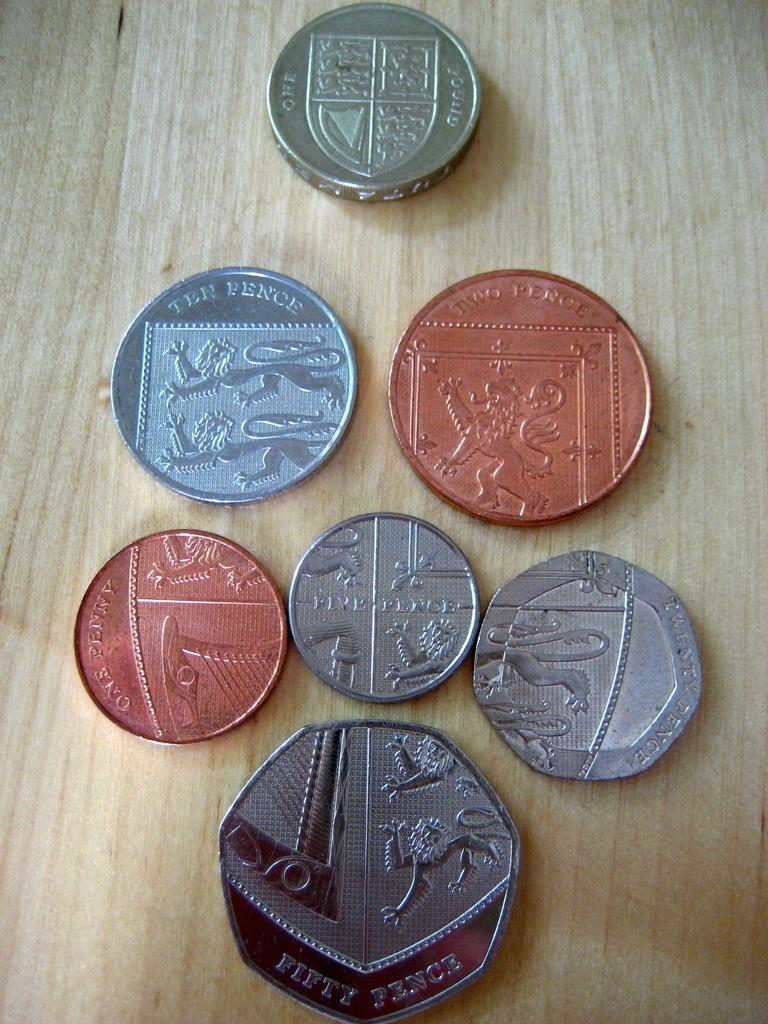Provide a one-sentence caption for the provided image. A group of European coins lined up to make a shield, with the bottom coin being worth fifty pence. 